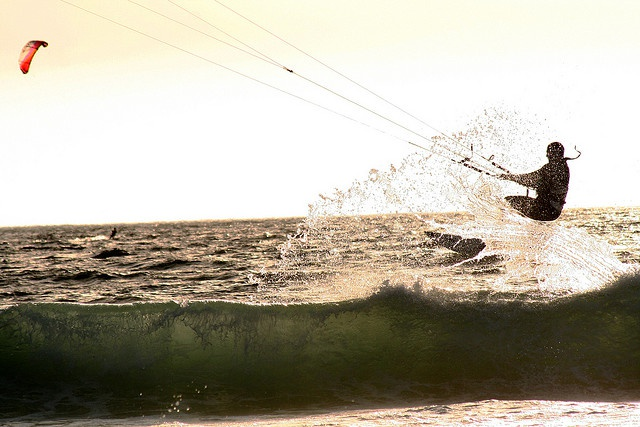Describe the objects in this image and their specific colors. I can see people in lightyellow, black, maroon, and gray tones, surfboard in lightyellow, black, and gray tones, and kite in lightyellow, tan, red, and salmon tones in this image. 